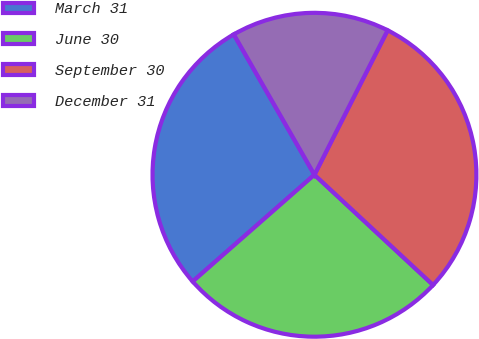<chart> <loc_0><loc_0><loc_500><loc_500><pie_chart><fcel>March 31<fcel>June 30<fcel>September 30<fcel>December 31<nl><fcel>28.16%<fcel>26.63%<fcel>29.46%<fcel>15.76%<nl></chart> 